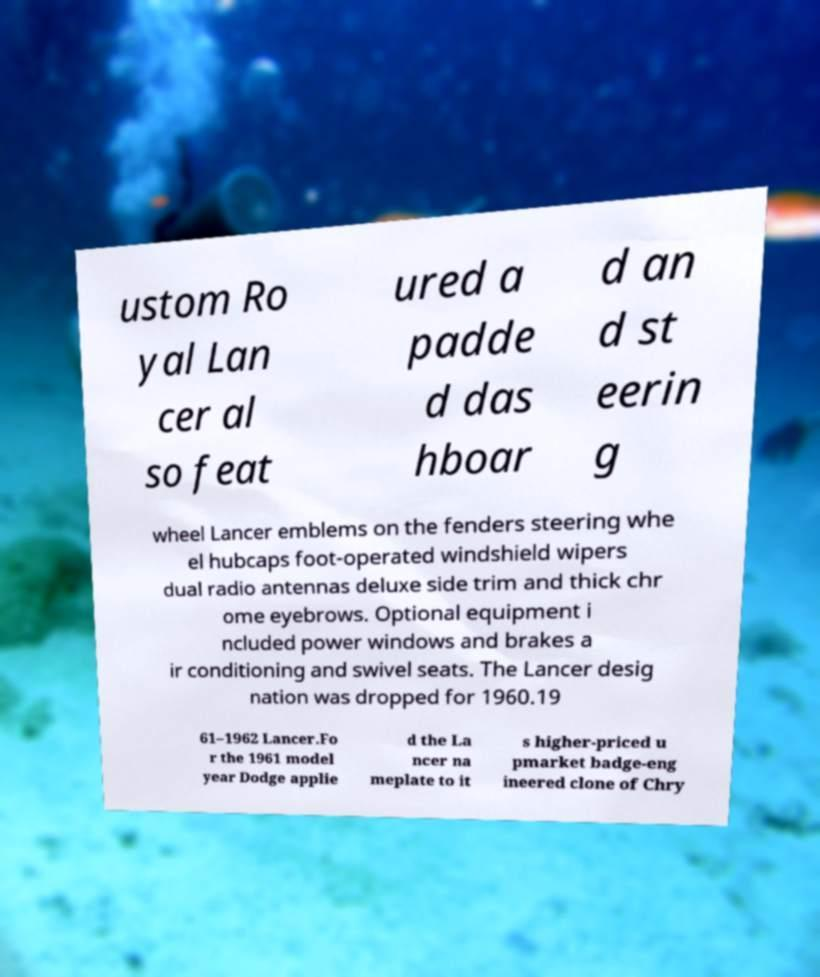Please read and relay the text visible in this image. What does it say? ustom Ro yal Lan cer al so feat ured a padde d das hboar d an d st eerin g wheel Lancer emblems on the fenders steering whe el hubcaps foot-operated windshield wipers dual radio antennas deluxe side trim and thick chr ome eyebrows. Optional equipment i ncluded power windows and brakes a ir conditioning and swivel seats. The Lancer desig nation was dropped for 1960.19 61–1962 Lancer.Fo r the 1961 model year Dodge applie d the La ncer na meplate to it s higher-priced u pmarket badge-eng ineered clone of Chry 